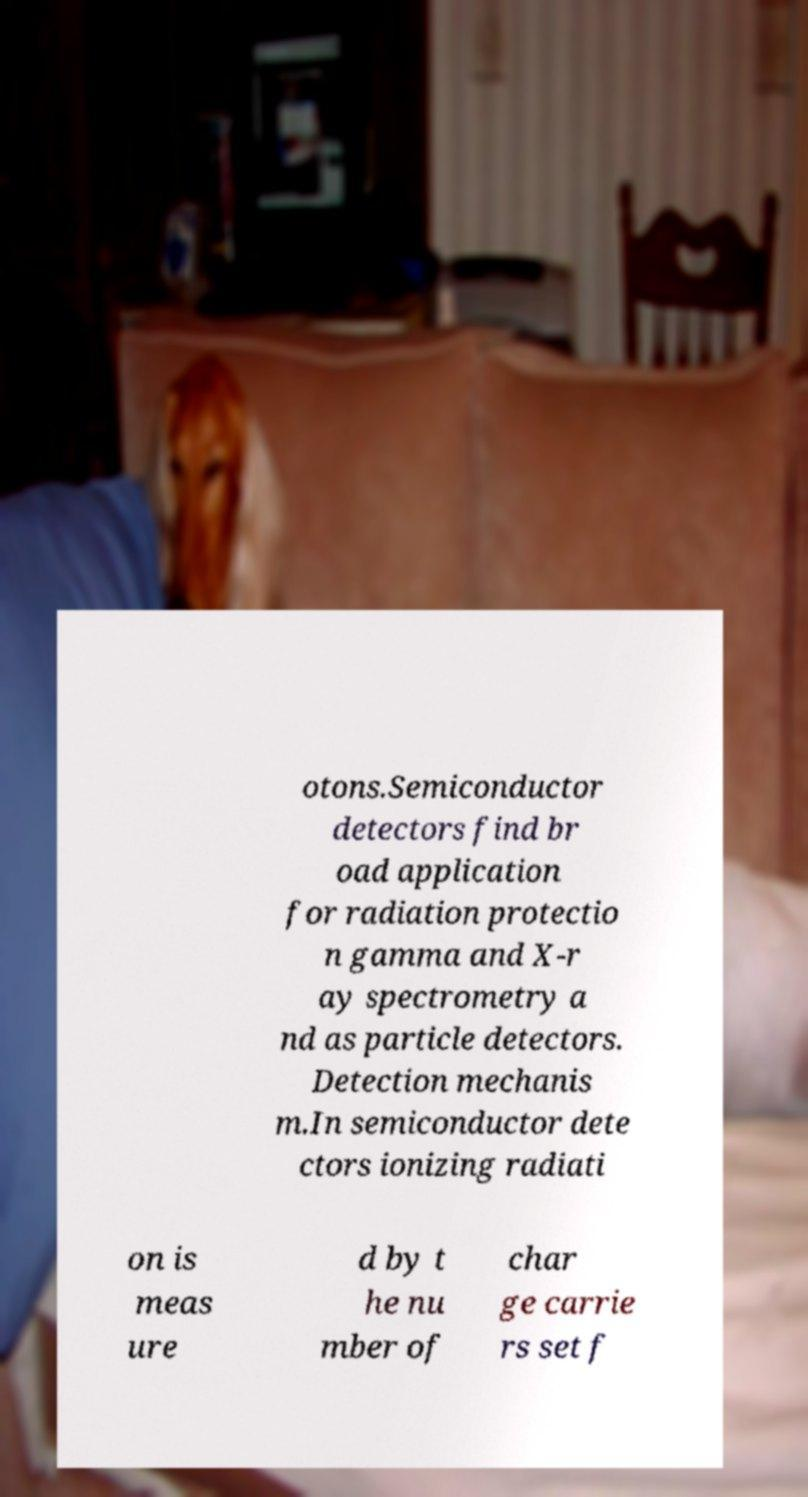Can you accurately transcribe the text from the provided image for me? otons.Semiconductor detectors find br oad application for radiation protectio n gamma and X-r ay spectrometry a nd as particle detectors. Detection mechanis m.In semiconductor dete ctors ionizing radiati on is meas ure d by t he nu mber of char ge carrie rs set f 